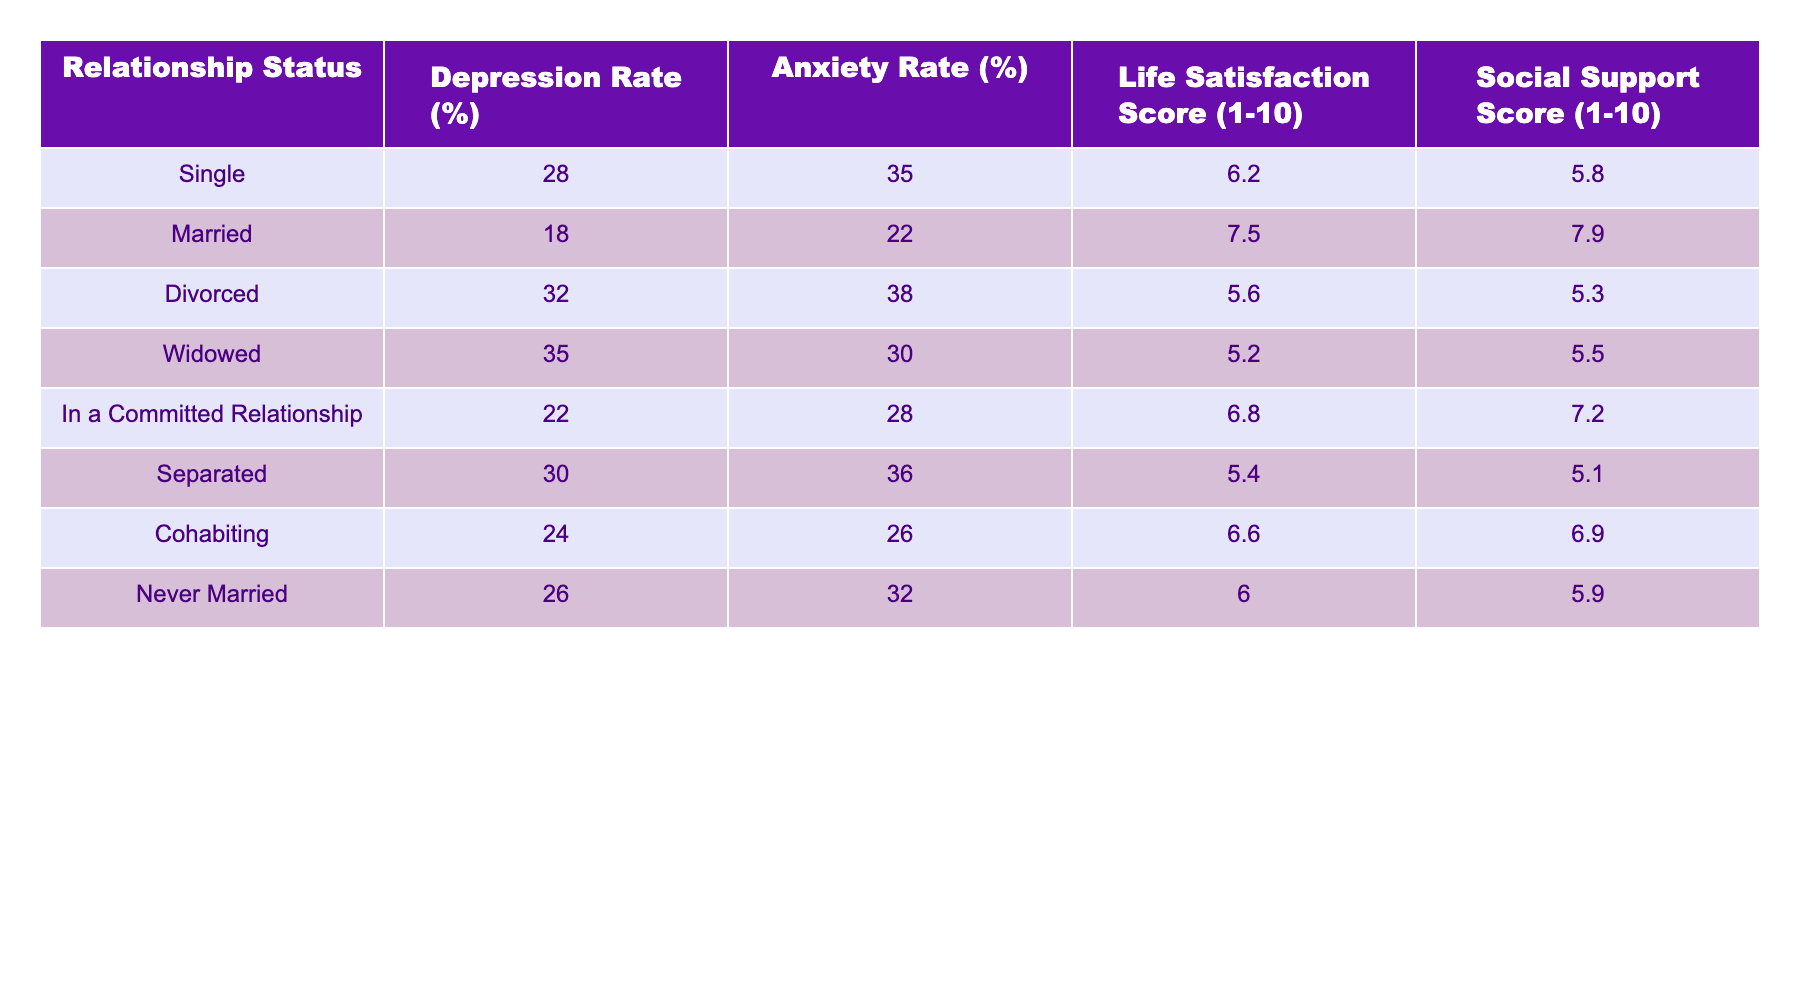What is the depression rate for individuals who are divorced? Referring to the table, the depression rate for individuals in the divorced category is directly listed as 32%.
Answer: 32% What is the life satisfaction score for individuals in a committed relationship? The table shows that the life satisfaction score for those in a committed relationship is 6.8.
Answer: 6.8 Which relationship status has the highest anxiety rate? By comparing the anxiety rates from the table, the widowed category has the highest rate at 30%.
Answer: 38% What is the average social support score for married and cohabiting individuals? The social support score for married individuals is 7.9 and for cohabiting individuals is 6.9. Adding them gives 7.9 + 6.9 = 14.8, and dividing by 2 gives an average of 14.8/2 = 7.4.
Answer: 7.4 Is the depression rate higher for singles or for those who are separated? The depression rate for singles is 28%, while for separated individuals it is 30%. Since 30% is greater than 28%, the statement is true.
Answer: Yes What is the overall life satisfaction score of individuals who are never married compared to those who are widowed? The life satisfaction score for never married individuals is 6.0, while for widowed individuals it is 5.2. Comparing these two scores shows that never married individuals have a higher life satisfaction score by 6.0 - 5.2 = 0.8.
Answer: Never married individuals have a higher score If we add the depression rates of all relationship statuses, what is the total? The depression rates are 28, 18, 32, 35, 22, 30, 24, and 26. Summing these gives 28 + 18 + 32 + 35 + 22 + 30 + 24 + 26 =  285.
Answer: 285 What percentage of individuals in committed relationships experience anxiety? The table lists the anxiety rate for individuals in committed relationships as 28%.
Answer: 28% Do divorced individuals report higher life satisfaction scores than widowed individuals? The life satisfaction score for divorced individuals is 5.6, while for widowed individuals it is 5.2. Since 5.6 is greater than 5.2, the statement is true.
Answer: Yes 